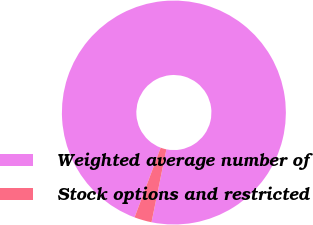Convert chart to OTSL. <chart><loc_0><loc_0><loc_500><loc_500><pie_chart><fcel>Weighted average number of<fcel>Stock options and restricted<nl><fcel>97.49%<fcel>2.51%<nl></chart> 